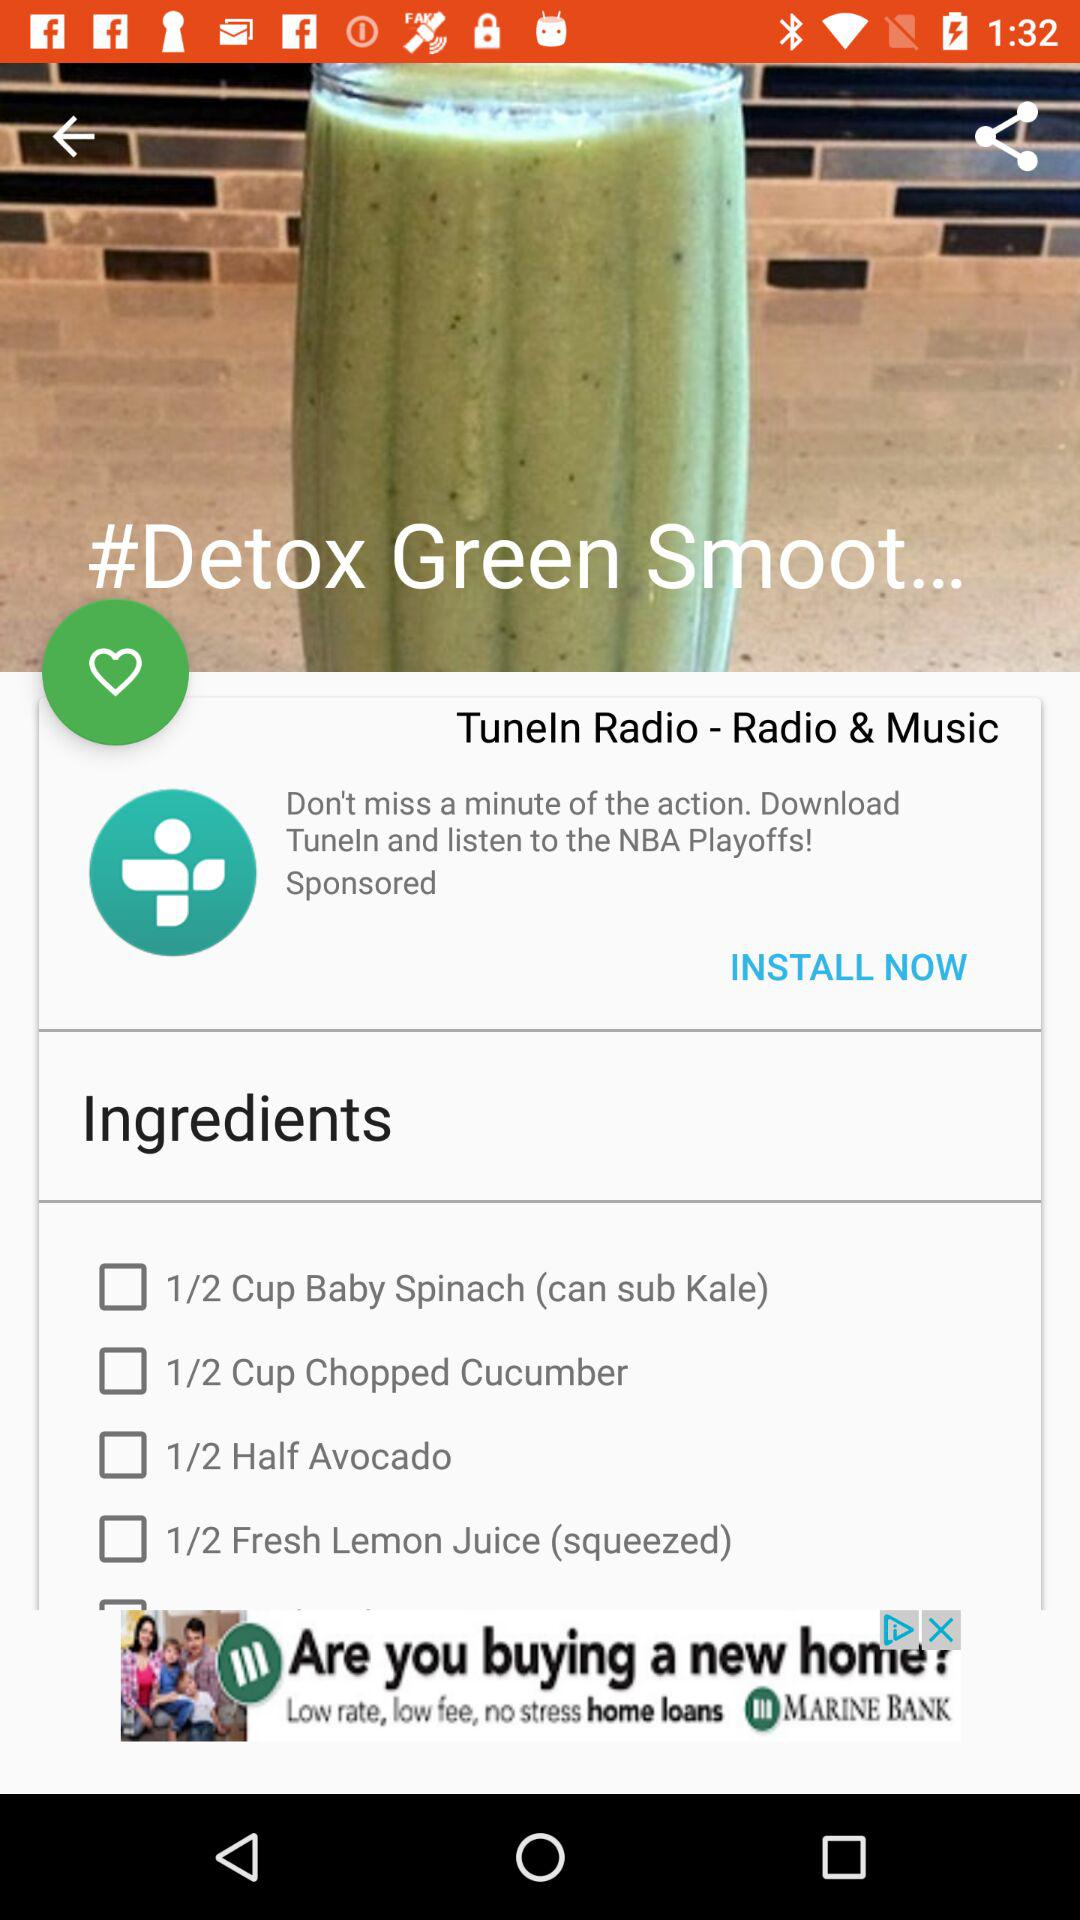How many calories are in the green detox smoothie?
When the provided information is insufficient, respond with <no answer>. <no answer> 